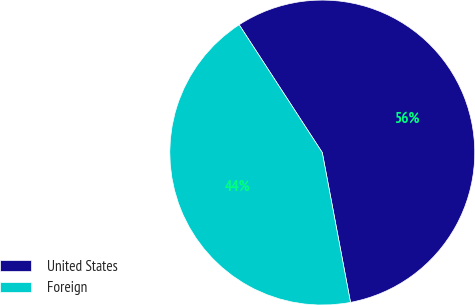Convert chart to OTSL. <chart><loc_0><loc_0><loc_500><loc_500><pie_chart><fcel>United States<fcel>Foreign<nl><fcel>56.21%<fcel>43.79%<nl></chart> 